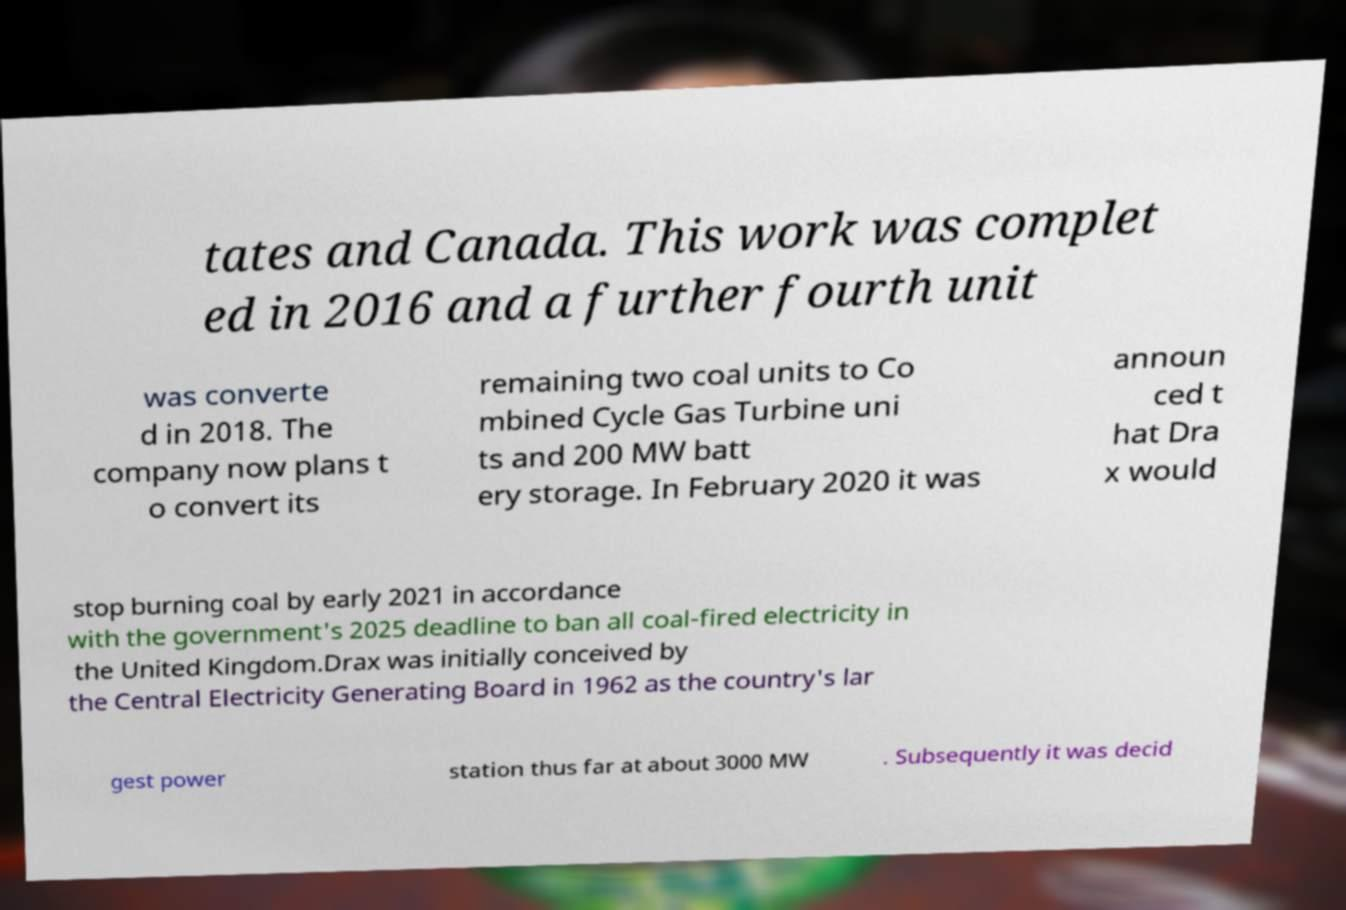What messages or text are displayed in this image? I need them in a readable, typed format. tates and Canada. This work was complet ed in 2016 and a further fourth unit was converte d in 2018. The company now plans t o convert its remaining two coal units to Co mbined Cycle Gas Turbine uni ts and 200 MW batt ery storage. In February 2020 it was announ ced t hat Dra x would stop burning coal by early 2021 in accordance with the government's 2025 deadline to ban all coal-fired electricity in the United Kingdom.Drax was initially conceived by the Central Electricity Generating Board in 1962 as the country's lar gest power station thus far at about 3000 MW . Subsequently it was decid 